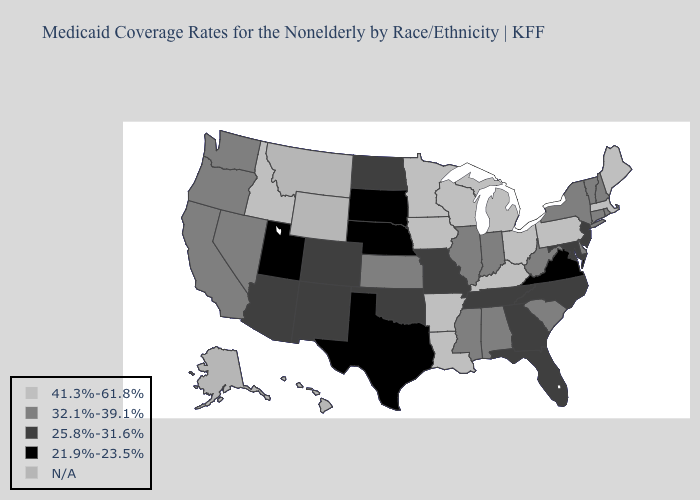What is the value of Missouri?
Be succinct. 25.8%-31.6%. Name the states that have a value in the range 21.9%-23.5%?
Be succinct. Nebraska, South Dakota, Texas, Utah, Virginia. Name the states that have a value in the range 41.3%-61.8%?
Be succinct. Arkansas, Idaho, Iowa, Kentucky, Louisiana, Maine, Massachusetts, Michigan, Minnesota, Ohio, Pennsylvania, Wisconsin. Does the first symbol in the legend represent the smallest category?
Quick response, please. No. Among the states that border New Jersey , which have the highest value?
Answer briefly. Pennsylvania. Name the states that have a value in the range 21.9%-23.5%?
Be succinct. Nebraska, South Dakota, Texas, Utah, Virginia. Does Tennessee have the lowest value in the USA?
Concise answer only. No. Among the states that border Idaho , does Oregon have the highest value?
Short answer required. Yes. Does the map have missing data?
Answer briefly. Yes. Name the states that have a value in the range N/A?
Write a very short answer. Alaska, Hawaii, Montana, Wyoming. What is the value of Maine?
Quick response, please. 41.3%-61.8%. What is the value of Mississippi?
Concise answer only. 32.1%-39.1%. Which states have the lowest value in the USA?
Write a very short answer. Nebraska, South Dakota, Texas, Utah, Virginia. What is the value of Minnesota?
Quick response, please. 41.3%-61.8%. Does the first symbol in the legend represent the smallest category?
Be succinct. No. 